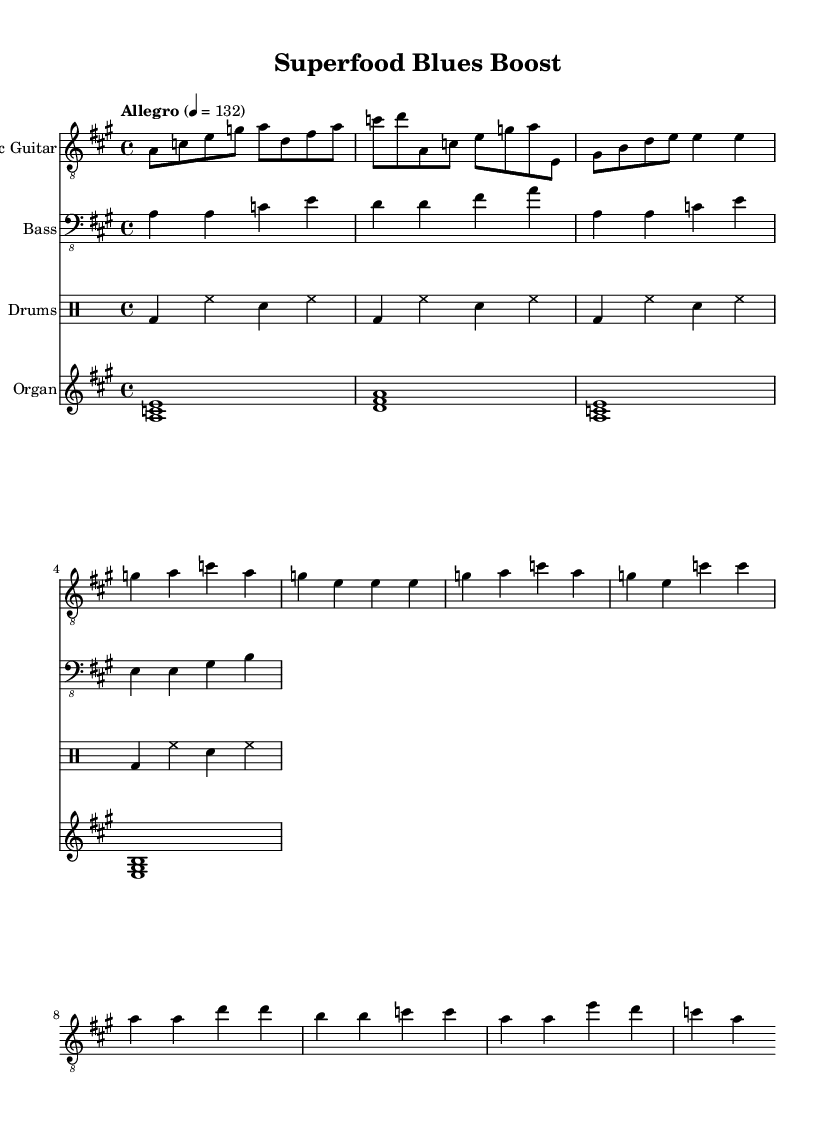What is the key signature of this music? The key signature for this piece is A major, which has three sharps (F#, C#, and G#). This can be identified at the beginning of the staff where the sharps are indicated.
Answer: A major What is the time signature of this piece? The time signature shown at the beginning is 4/4, which indicates that there are four beats per measure and the quarter note gets one beat. This is visually represented by the numbers in the time signature symbol.
Answer: 4/4 What is the tempo marking of this composition? The tempo marking at the beginning indicates "Allegro," which typically means a fast pace, and the exact speed is specified as 132 beats per minute. This is indicated with the word "Allegro" and the number noted in the part containing global information.
Answer: Allegro How many measures are in the verse section? There are four measures in the verse section as indicated by the notated melody line. The measures can be counted in the section marked "Verse (Melody)" where the notes are grouped.
Answer: Four measures Which instrument plays the sustained chords? The organ plays the sustained chords as notated in the section for the organ part. The chord symbols like <a c e> indicate the chords sustained by the organ, showing it as a chord-playing instrument.
Answer: Organ What musical elements are characteristic of the electric blues style present in this sheet music? The electric blues style is characterized by the use of electric guitar riffs, a strong bass line, and a drum pattern that supports the upbeat rhythm, identifiable through the specific instrumental parts laid out in the score.
Answer: Electric guitar riffs, strong bass line, drum pattern What is the primary melody's highest note in the chorus? The highest note in the chorus melody is E, as seen in the notation of the melody section where E is reached in the fourth measure of the chorus.
Answer: E 